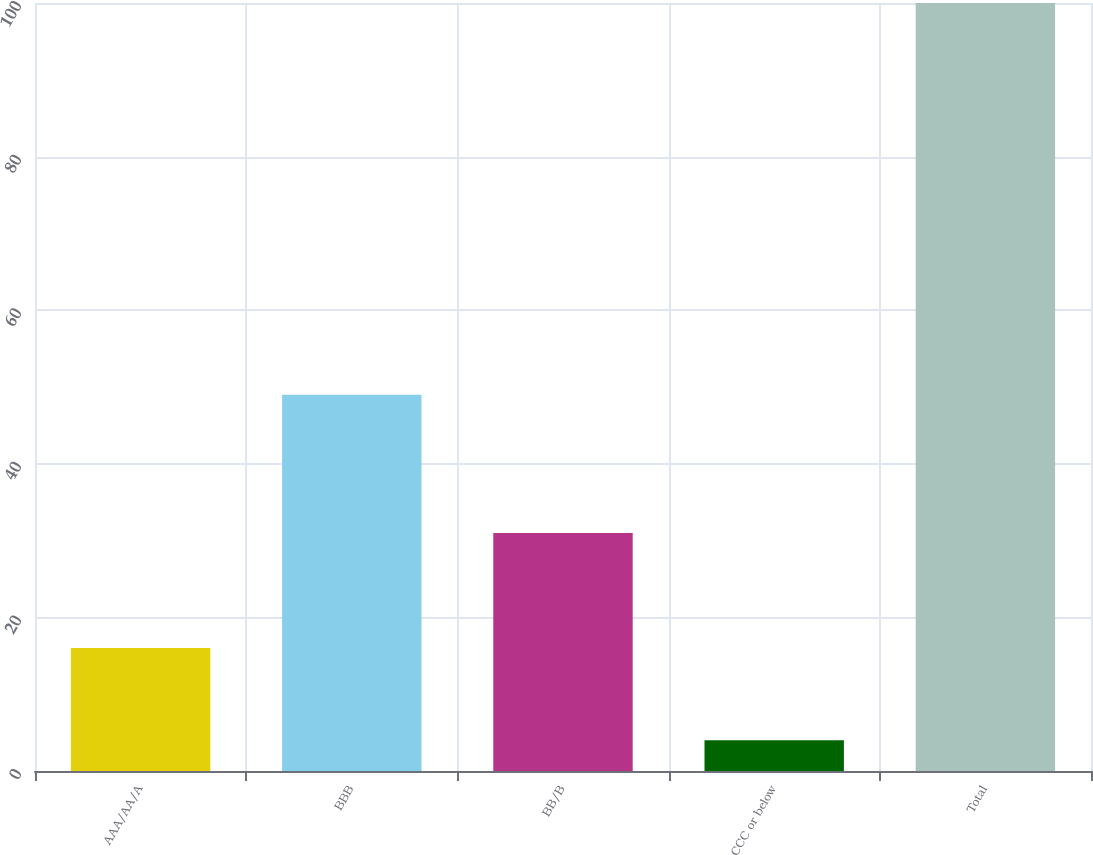Convert chart to OTSL. <chart><loc_0><loc_0><loc_500><loc_500><bar_chart><fcel>AAA/AA/A<fcel>BBB<fcel>BB/B<fcel>CCC or below<fcel>Total<nl><fcel>16<fcel>49<fcel>31<fcel>4<fcel>100<nl></chart> 